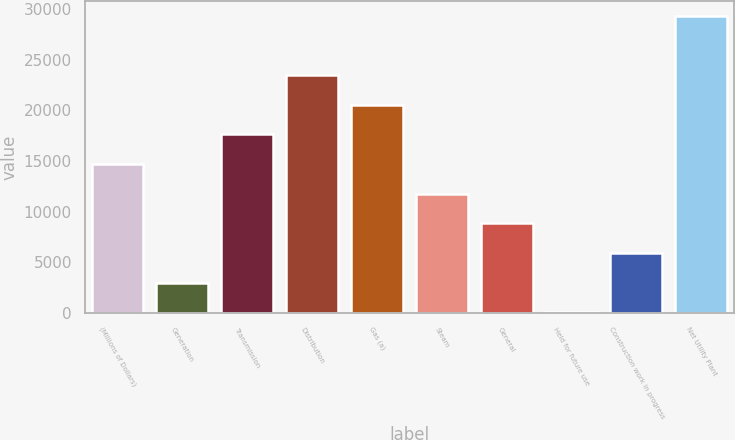Convert chart. <chart><loc_0><loc_0><loc_500><loc_500><bar_chart><fcel>(Millions of Dollars)<fcel>Generation<fcel>Transmission<fcel>Distribution<fcel>Gas (a)<fcel>Steam<fcel>General<fcel>Held for future use<fcel>Construction work in progress<fcel>Net Utility Plant<nl><fcel>14701<fcel>3001<fcel>17626<fcel>23476<fcel>20551<fcel>11776<fcel>8851<fcel>76<fcel>5926<fcel>29326<nl></chart> 